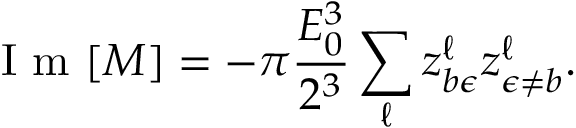Convert formula to latex. <formula><loc_0><loc_0><loc_500><loc_500>I m [ M ] = - \pi \frac { E _ { 0 } ^ { 3 } } { 2 ^ { 3 } } \sum _ { \ell } z _ { b \epsilon } ^ { \ell } z _ { \epsilon \neq b } ^ { \ell } .</formula> 